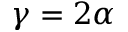Convert formula to latex. <formula><loc_0><loc_0><loc_500><loc_500>\gamma = 2 \alpha</formula> 